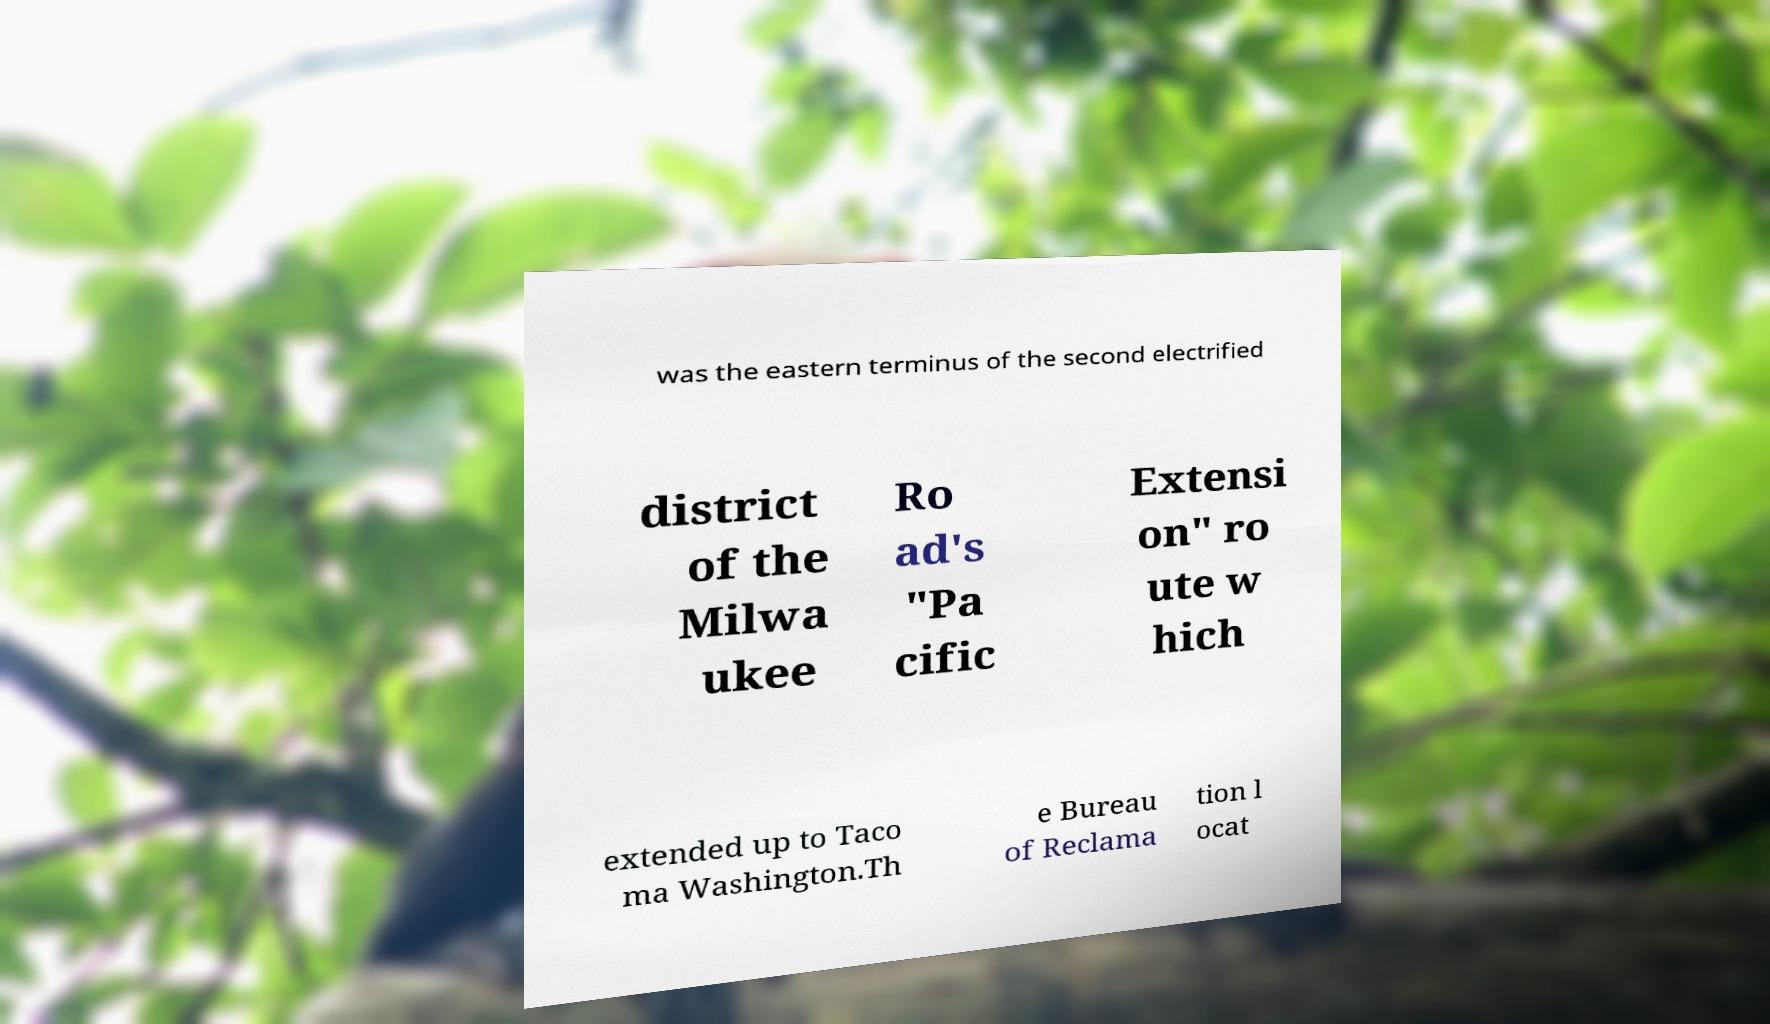Can you accurately transcribe the text from the provided image for me? was the eastern terminus of the second electrified district of the Milwa ukee Ro ad's "Pa cific Extensi on" ro ute w hich extended up to Taco ma Washington.Th e Bureau of Reclama tion l ocat 